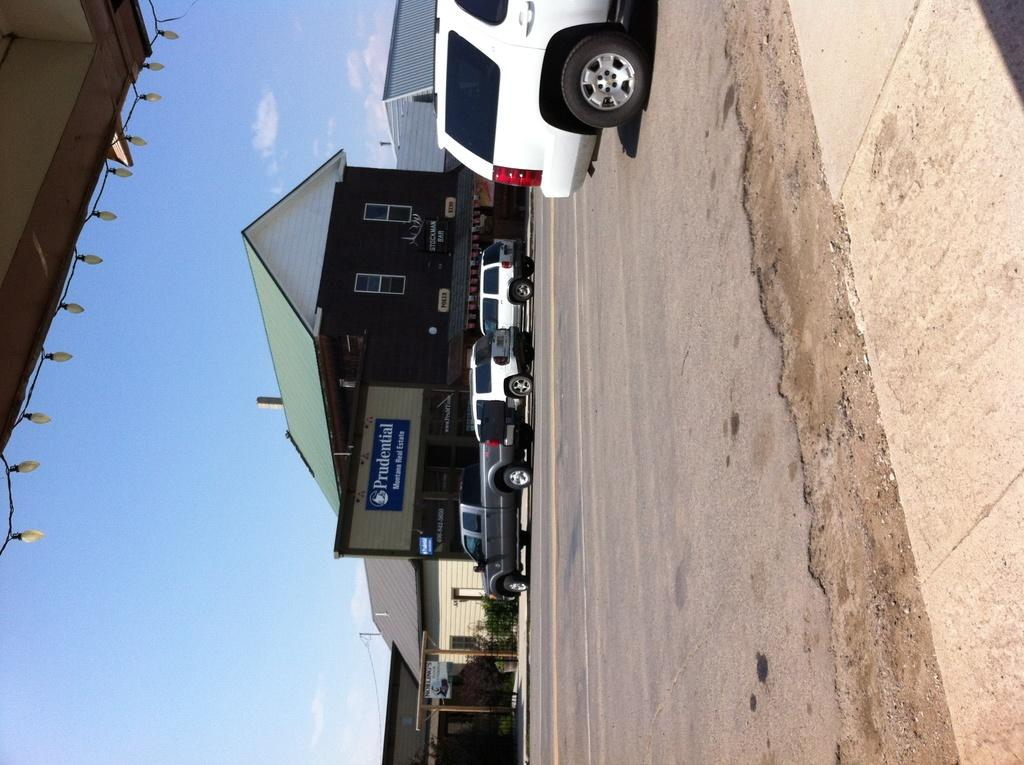What can be seen on the road in the image? There are vehicles on the road in the image. What is the color scheme of the building in the image? The building in the image has green and brown colors. How would you describe the color of the sky in the image? The sky is white and blue in the image. Can you see a robin perched on the building in the image? There is no robin present in the image. What type of motion is occurring in the image? The image is a still photograph, so there is no motion occurring within the image itself. 